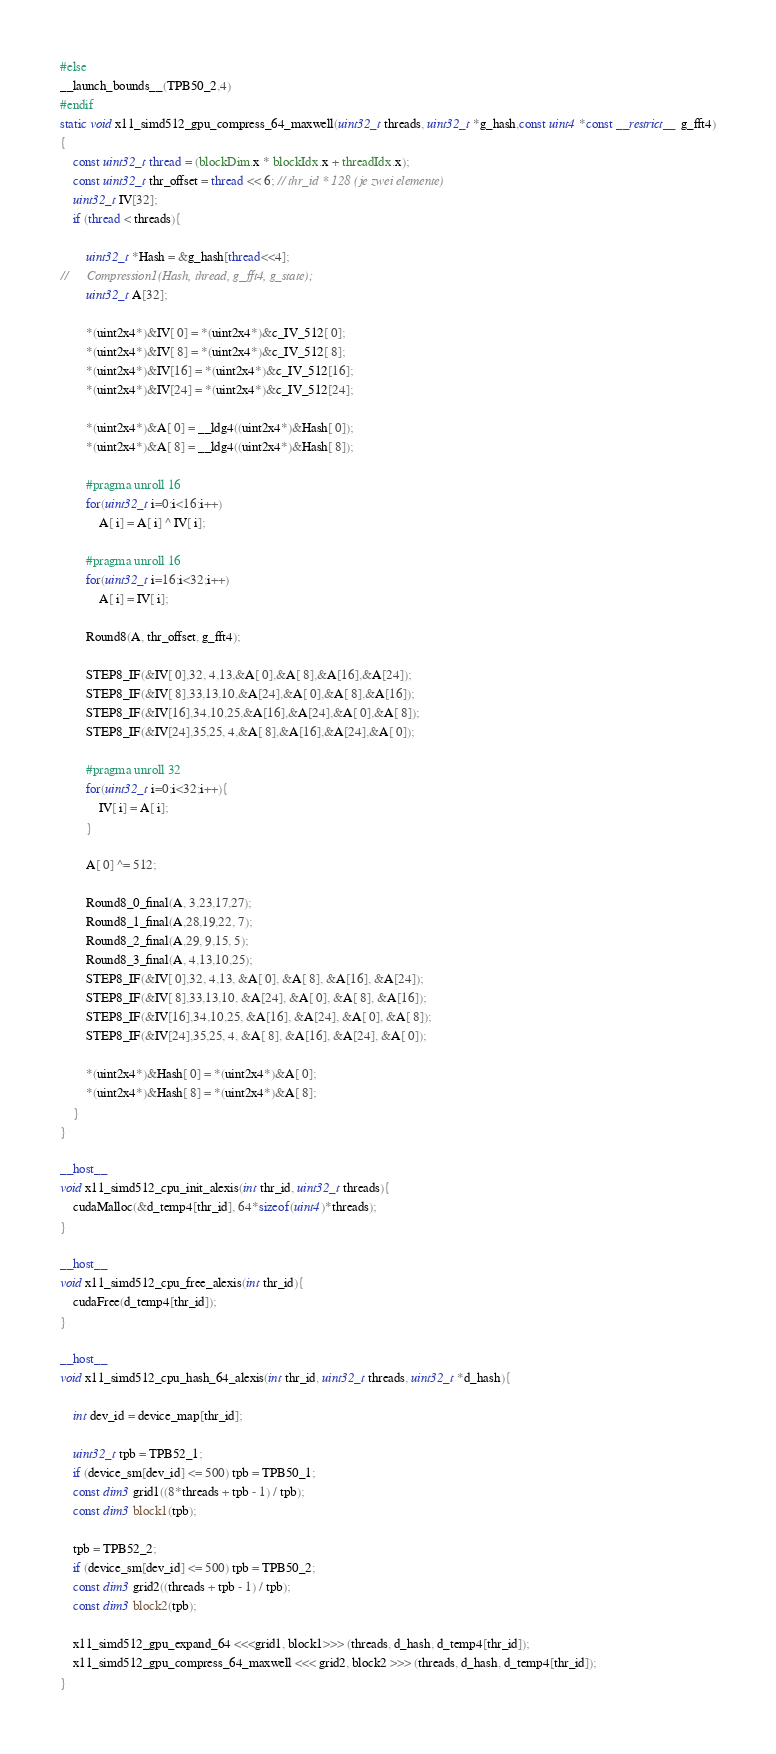<code> <loc_0><loc_0><loc_500><loc_500><_Cuda_>#else
__launch_bounds__(TPB50_2,4)
#endif
static void x11_simd512_gpu_compress_64_maxwell(uint32_t threads, uint32_t *g_hash,const uint4 *const __restrict__ g_fft4)
{
	const uint32_t thread = (blockDim.x * blockIdx.x + threadIdx.x);
	const uint32_t thr_offset = thread << 6; // thr_id * 128 (je zwei elemente)
	uint32_t IV[32];
	if (thread < threads){

		uint32_t *Hash = &g_hash[thread<<4];
//		Compression1(Hash, thread, g_fft4, g_state);
		uint32_t A[32];

		*(uint2x4*)&IV[ 0] = *(uint2x4*)&c_IV_512[ 0];
		*(uint2x4*)&IV[ 8] = *(uint2x4*)&c_IV_512[ 8];
		*(uint2x4*)&IV[16] = *(uint2x4*)&c_IV_512[16];
		*(uint2x4*)&IV[24] = *(uint2x4*)&c_IV_512[24];

		*(uint2x4*)&A[ 0] = __ldg4((uint2x4*)&Hash[ 0]);
		*(uint2x4*)&A[ 8] = __ldg4((uint2x4*)&Hash[ 8]);

		#pragma unroll 16
		for(uint32_t i=0;i<16;i++)
			A[ i] = A[ i] ^ IV[ i];

		#pragma unroll 16
		for(uint32_t i=16;i<32;i++)
			A[ i] = IV[ i];

		Round8(A, thr_offset, g_fft4);
		
		STEP8_IF(&IV[ 0],32, 4,13,&A[ 0],&A[ 8],&A[16],&A[24]);
		STEP8_IF(&IV[ 8],33,13,10,&A[24],&A[ 0],&A[ 8],&A[16]);
		STEP8_IF(&IV[16],34,10,25,&A[16],&A[24],&A[ 0],&A[ 8]);
		STEP8_IF(&IV[24],35,25, 4,&A[ 8],&A[16],&A[24],&A[ 0]);

		#pragma unroll 32
		for(uint32_t i=0;i<32;i++){
			IV[ i] = A[ i];
		}
		
		A[ 0] ^= 512;

		Round8_0_final(A, 3,23,17,27);
		Round8_1_final(A,28,19,22, 7);
		Round8_2_final(A,29, 9,15, 5);
		Round8_3_final(A, 4,13,10,25);
		STEP8_IF(&IV[ 0],32, 4,13, &A[ 0], &A[ 8], &A[16], &A[24]);
		STEP8_IF(&IV[ 8],33,13,10, &A[24], &A[ 0], &A[ 8], &A[16]);
		STEP8_IF(&IV[16],34,10,25, &A[16], &A[24], &A[ 0], &A[ 8]);
		STEP8_IF(&IV[24],35,25, 4, &A[ 8], &A[16], &A[24], &A[ 0]);

		*(uint2x4*)&Hash[ 0] = *(uint2x4*)&A[ 0];
		*(uint2x4*)&Hash[ 8] = *(uint2x4*)&A[ 8];
	}
}

__host__
void x11_simd512_cpu_init_alexis(int thr_id, uint32_t threads){
	cudaMalloc(&d_temp4[thr_id], 64*sizeof(uint4)*threads);
}

__host__
void x11_simd512_cpu_free_alexis(int thr_id){
	cudaFree(d_temp4[thr_id]);
}

__host__
void x11_simd512_cpu_hash_64_alexis(int thr_id, uint32_t threads, uint32_t *d_hash){

	int dev_id = device_map[thr_id];

	uint32_t tpb = TPB52_1;
	if (device_sm[dev_id] <= 500) tpb = TPB50_1;
	const dim3 grid1((8*threads + tpb - 1) / tpb);
	const dim3 block1(tpb);

	tpb = TPB52_2;
	if (device_sm[dev_id] <= 500) tpb = TPB50_2;
	const dim3 grid2((threads + tpb - 1) / tpb);
	const dim3 block2(tpb);
	
	x11_simd512_gpu_expand_64 <<<grid1, block1>>> (threads, d_hash, d_temp4[thr_id]);
	x11_simd512_gpu_compress_64_maxwell <<< grid2, block2 >>> (threads, d_hash, d_temp4[thr_id]);
}
</code> 